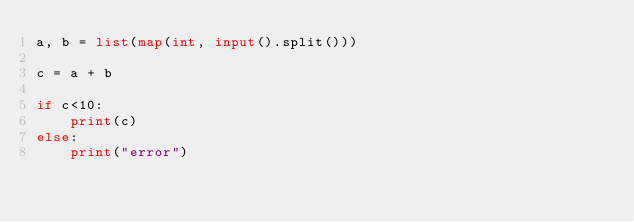<code> <loc_0><loc_0><loc_500><loc_500><_Python_>a, b = list(map(int, input().split()))

c = a + b 

if c<10:
    print(c)
else:
    print("error")</code> 